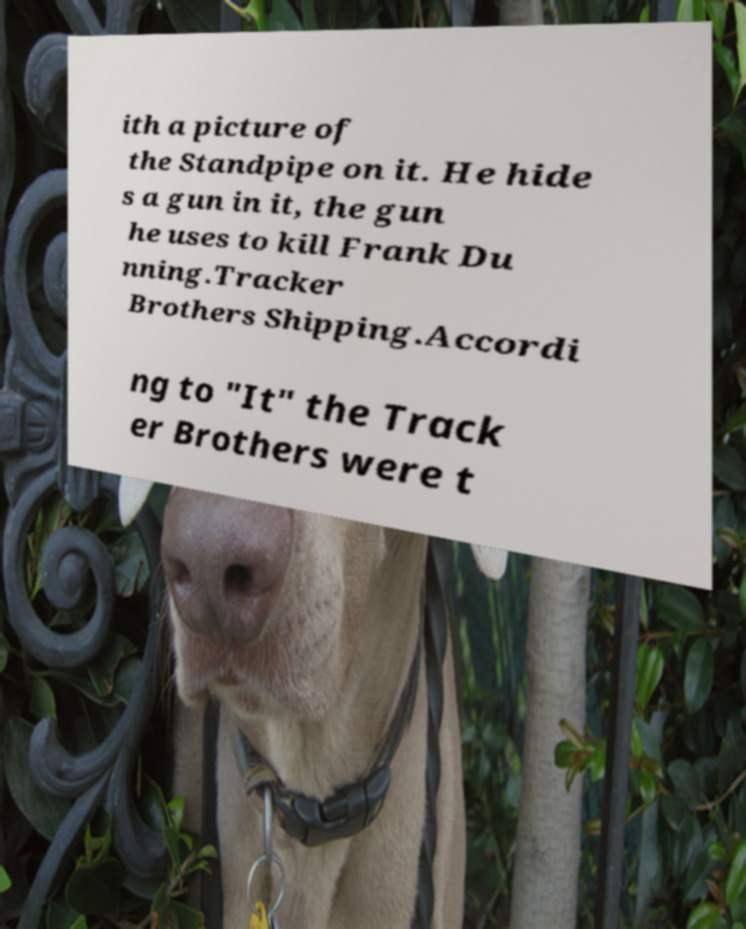What messages or text are displayed in this image? I need them in a readable, typed format. ith a picture of the Standpipe on it. He hide s a gun in it, the gun he uses to kill Frank Du nning.Tracker Brothers Shipping.Accordi ng to "It" the Track er Brothers were t 